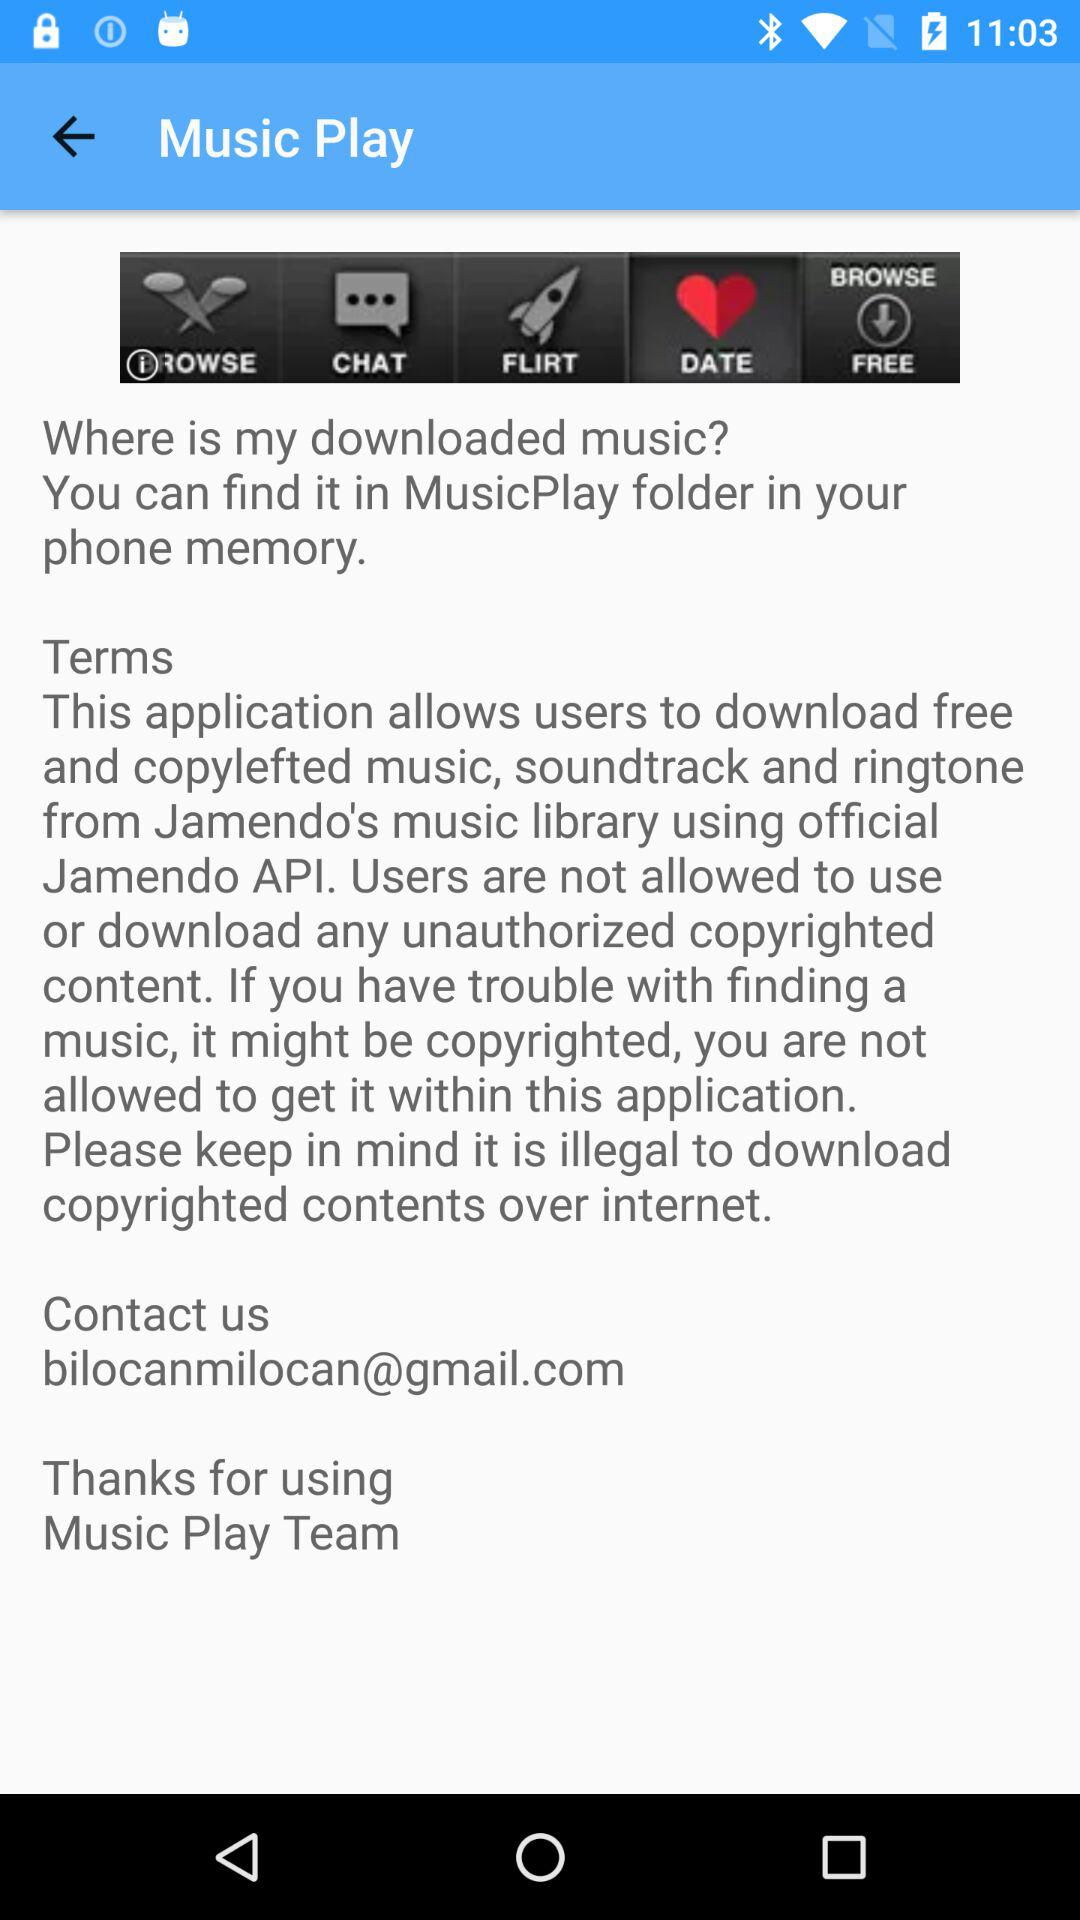What is the application name? The application name is "Music Play". 